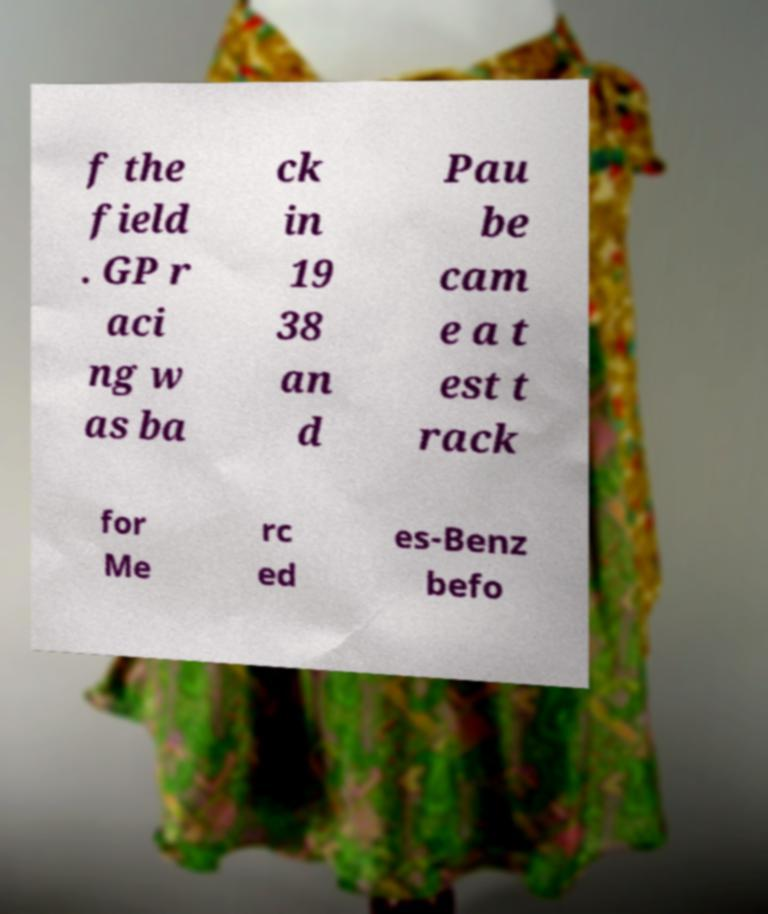There's text embedded in this image that I need extracted. Can you transcribe it verbatim? f the field . GP r aci ng w as ba ck in 19 38 an d Pau be cam e a t est t rack for Me rc ed es-Benz befo 